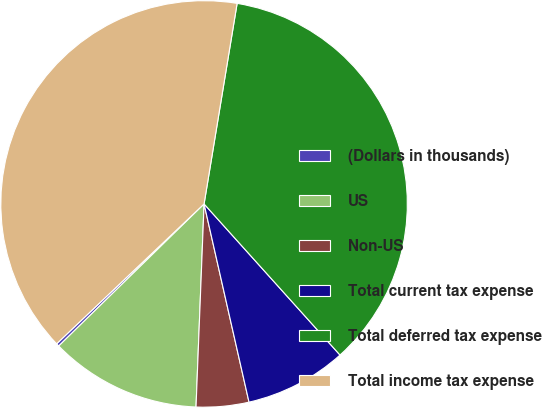Convert chart to OTSL. <chart><loc_0><loc_0><loc_500><loc_500><pie_chart><fcel>(Dollars in thousands)<fcel>US<fcel>Non-US<fcel>Total current tax expense<fcel>Total deferred tax expense<fcel>Total income tax expense<nl><fcel>0.24%<fcel>12.05%<fcel>4.18%<fcel>8.11%<fcel>35.74%<fcel>39.68%<nl></chart> 